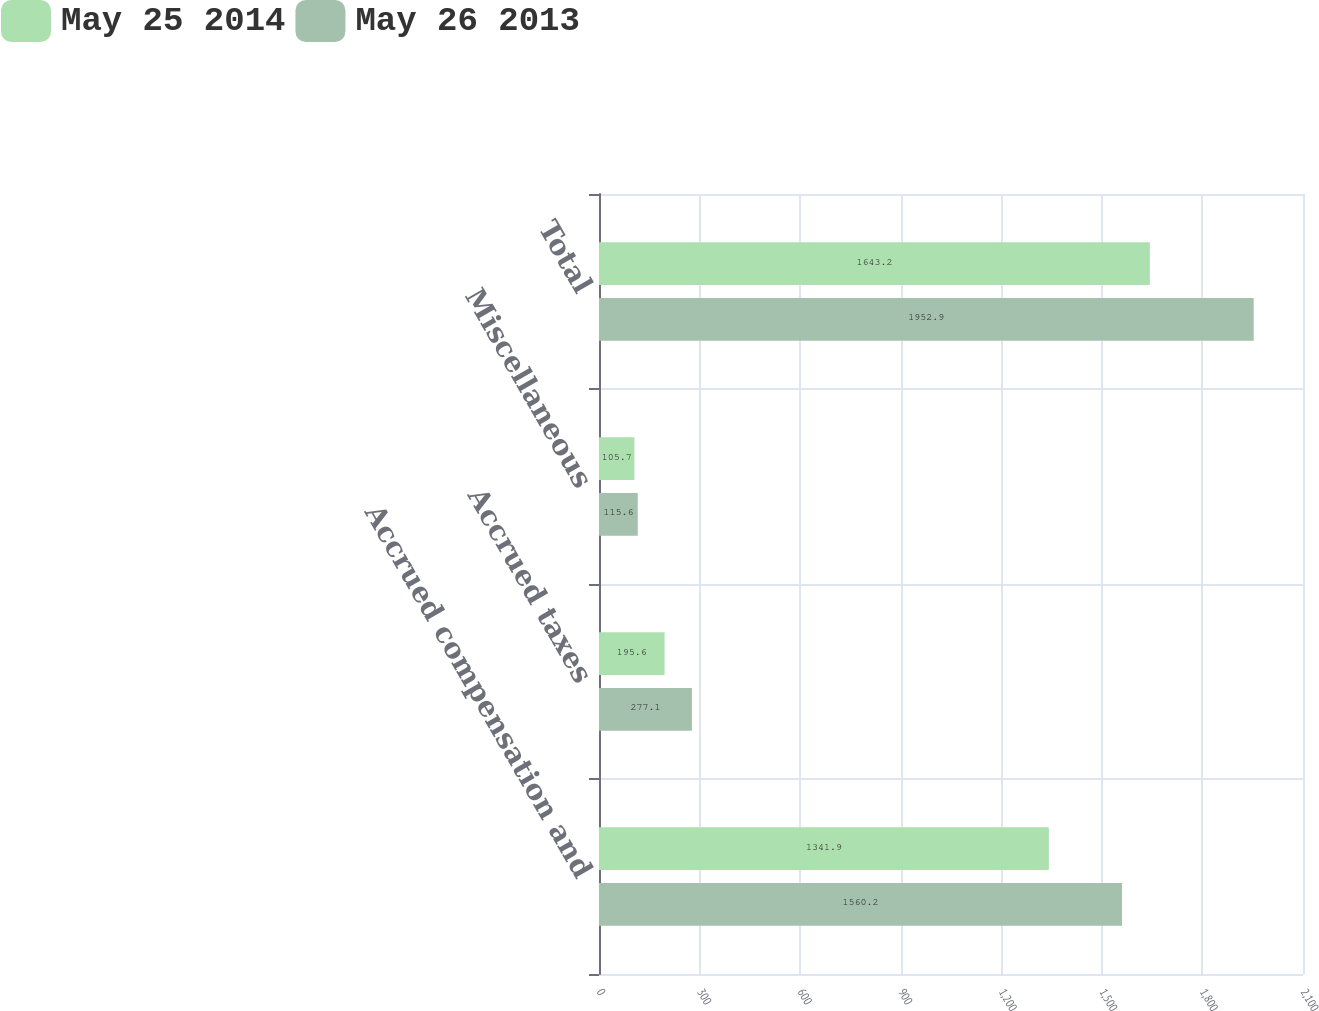Convert chart. <chart><loc_0><loc_0><loc_500><loc_500><stacked_bar_chart><ecel><fcel>Accrued compensation and<fcel>Accrued taxes<fcel>Miscellaneous<fcel>Total<nl><fcel>May 25 2014<fcel>1341.9<fcel>195.6<fcel>105.7<fcel>1643.2<nl><fcel>May 26 2013<fcel>1560.2<fcel>277.1<fcel>115.6<fcel>1952.9<nl></chart> 